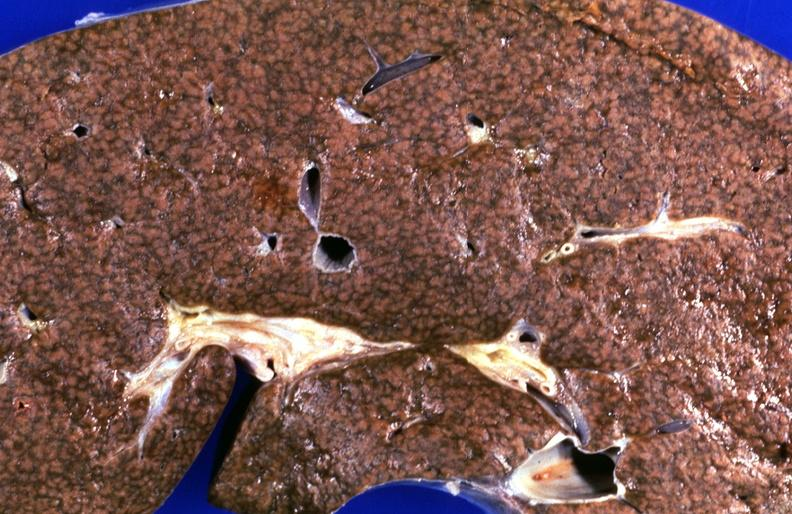does this image show kidney, hemochromatosis?
Answer the question using a single word or phrase. Yes 